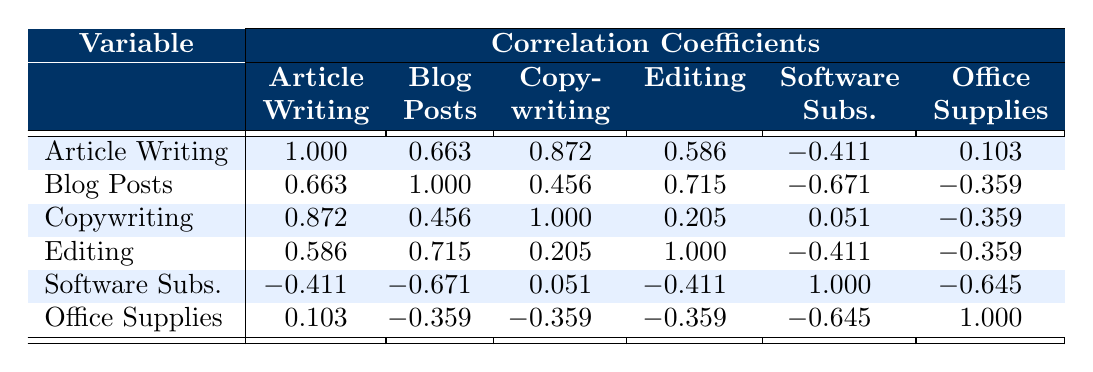What is the correlation coefficient between article writing and blog posts? The table's first row, second column shows the correlation coefficient between article writing and blog posts, which is 0.663.
Answer: 0.663 Which income source has the highest correlation with copywriting? Looking through the table, the row for copywriting lists the highest correlation with article writing at 0.872.
Answer: Article writing Is the correlation between editing and office supplies positive or negative? The table indicates that the correlation coefficient between editing and office supplies is -0.359, which is negative.
Answer: Negative What is the average correlation coefficient for software subscriptions with other variables? The software subscriptions row displays correlation coefficients of -0.411, -0.671, 0.051, -0.411, and -0.645. Summing these coefficients gives -2.125, and dividing by 5 (the number of coefficients) results in an average of -0.425.
Answer: -0.425 Does the table indicate that there's a strong correlation between blog posts and editing? The correlation coefficient between blog posts and editing is 0.715, which is greater than 0.6, indicating a strong correlation.
Answer: Yes What is the difference between the highest and lowest correlation coefficients for office supplies? From the table, the correlation coefficients for office supplies are 0.103 (with article writing) and -0.645 (with software subscriptions). The difference is -0.645 - 0.103 = -0.748.
Answer: -0.748 Which source shows the lowest correlation with editing? By examining the table, the lowest correlation with editing is found with copywriting, which has a correlation of 0.205.
Answer: 0.205 How many income sources have a correlation greater than 0.6 with article writing? The table's row for article writing shows three correlations greater than 0.6: with blog posts (0.663), copywriting (0.872), and editing (0.586). Therefore, there are 2 sources with a correlation greater than 0.6.
Answer: 2 